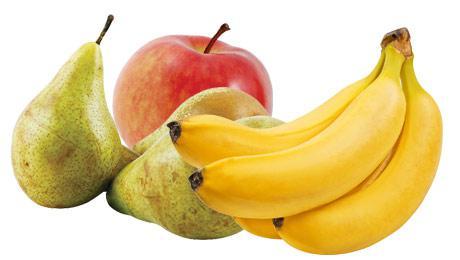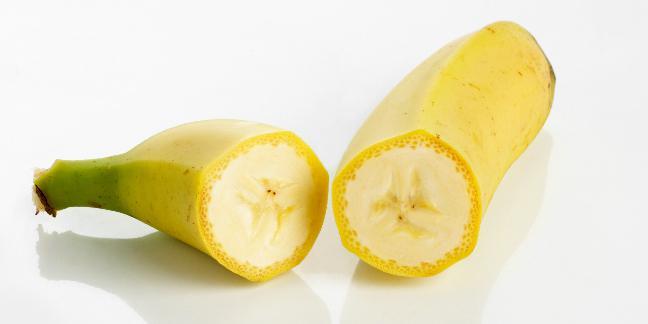The first image is the image on the left, the second image is the image on the right. For the images displayed, is the sentence "In one image, the inside of a banana is visible." factually correct? Answer yes or no. Yes. The first image is the image on the left, the second image is the image on the right. For the images shown, is this caption "The left image includes unpeeled bananas with at least one other item, and the right image shows what is under a banana peel." true? Answer yes or no. Yes. 